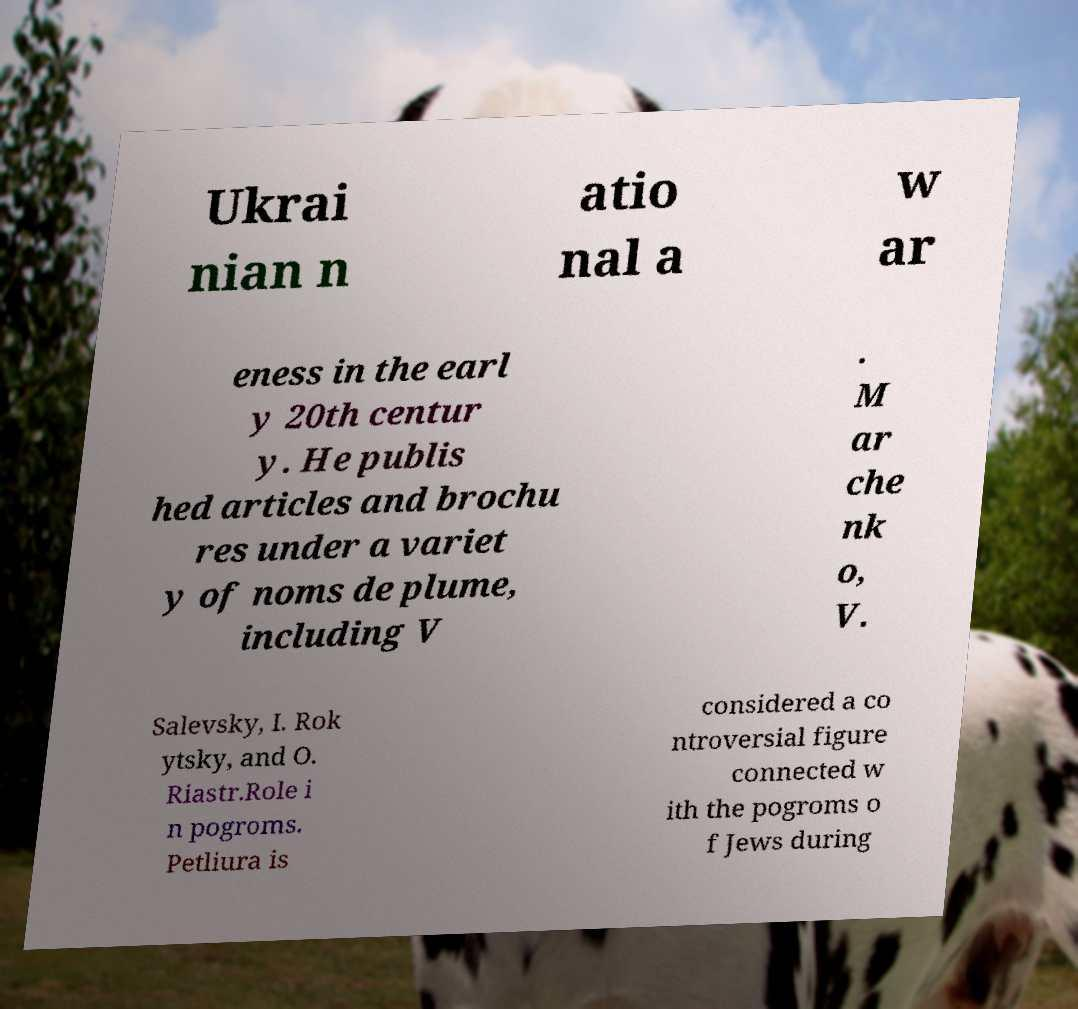Can you accurately transcribe the text from the provided image for me? Ukrai nian n atio nal a w ar eness in the earl y 20th centur y. He publis hed articles and brochu res under a variet y of noms de plume, including V . M ar che nk o, V. Salevsky, I. Rok ytsky, and O. Riastr.Role i n pogroms. Petliura is considered a co ntroversial figure connected w ith the pogroms o f Jews during 